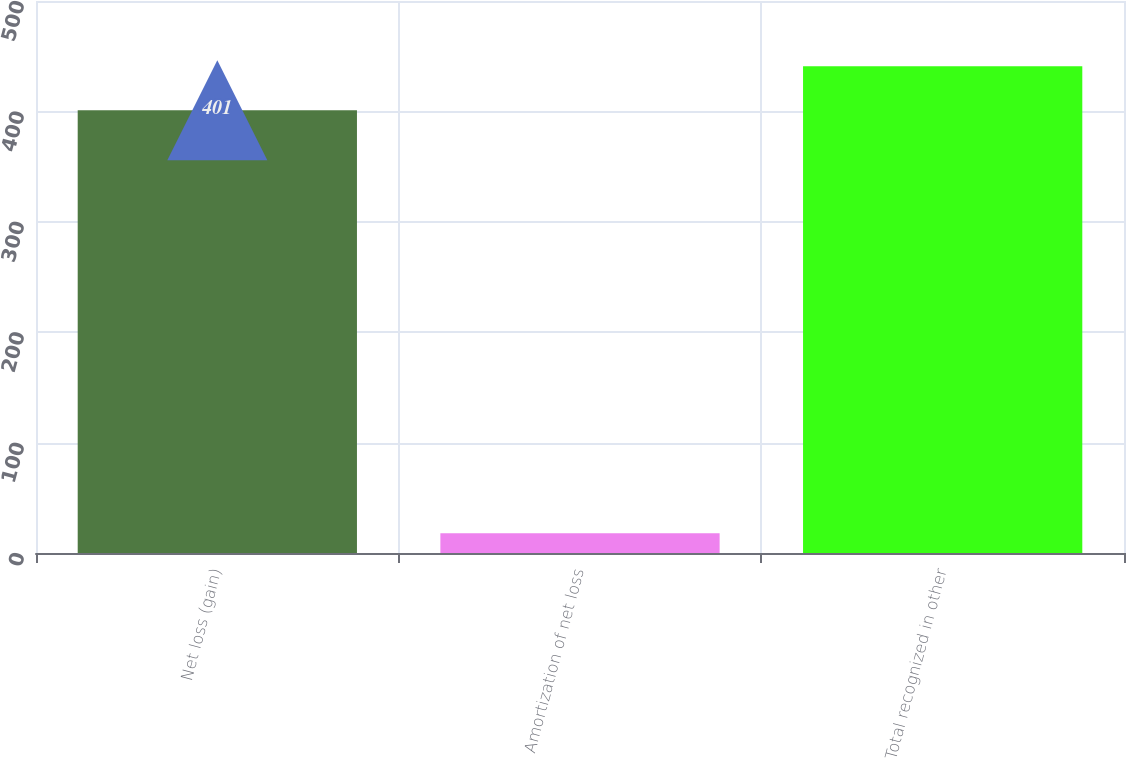<chart> <loc_0><loc_0><loc_500><loc_500><bar_chart><fcel>Net loss (gain)<fcel>Amortization of net loss<fcel>Total recognized in other<nl><fcel>401<fcel>18<fcel>440.9<nl></chart> 